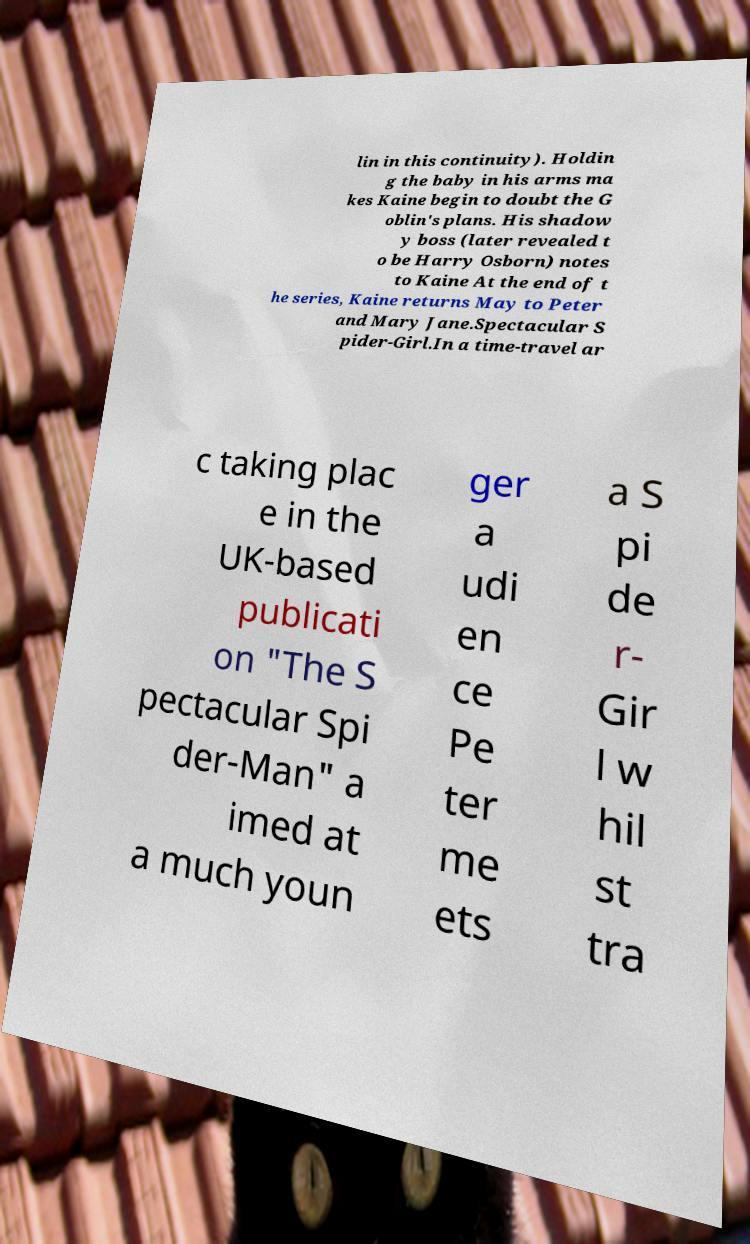Can you read and provide the text displayed in the image?This photo seems to have some interesting text. Can you extract and type it out for me? lin in this continuity). Holdin g the baby in his arms ma kes Kaine begin to doubt the G oblin's plans. His shadow y boss (later revealed t o be Harry Osborn) notes to Kaine At the end of t he series, Kaine returns May to Peter and Mary Jane.Spectacular S pider-Girl.In a time-travel ar c taking plac e in the UK-based publicati on "The S pectacular Spi der-Man" a imed at a much youn ger a udi en ce Pe ter me ets a S pi de r- Gir l w hil st tra 